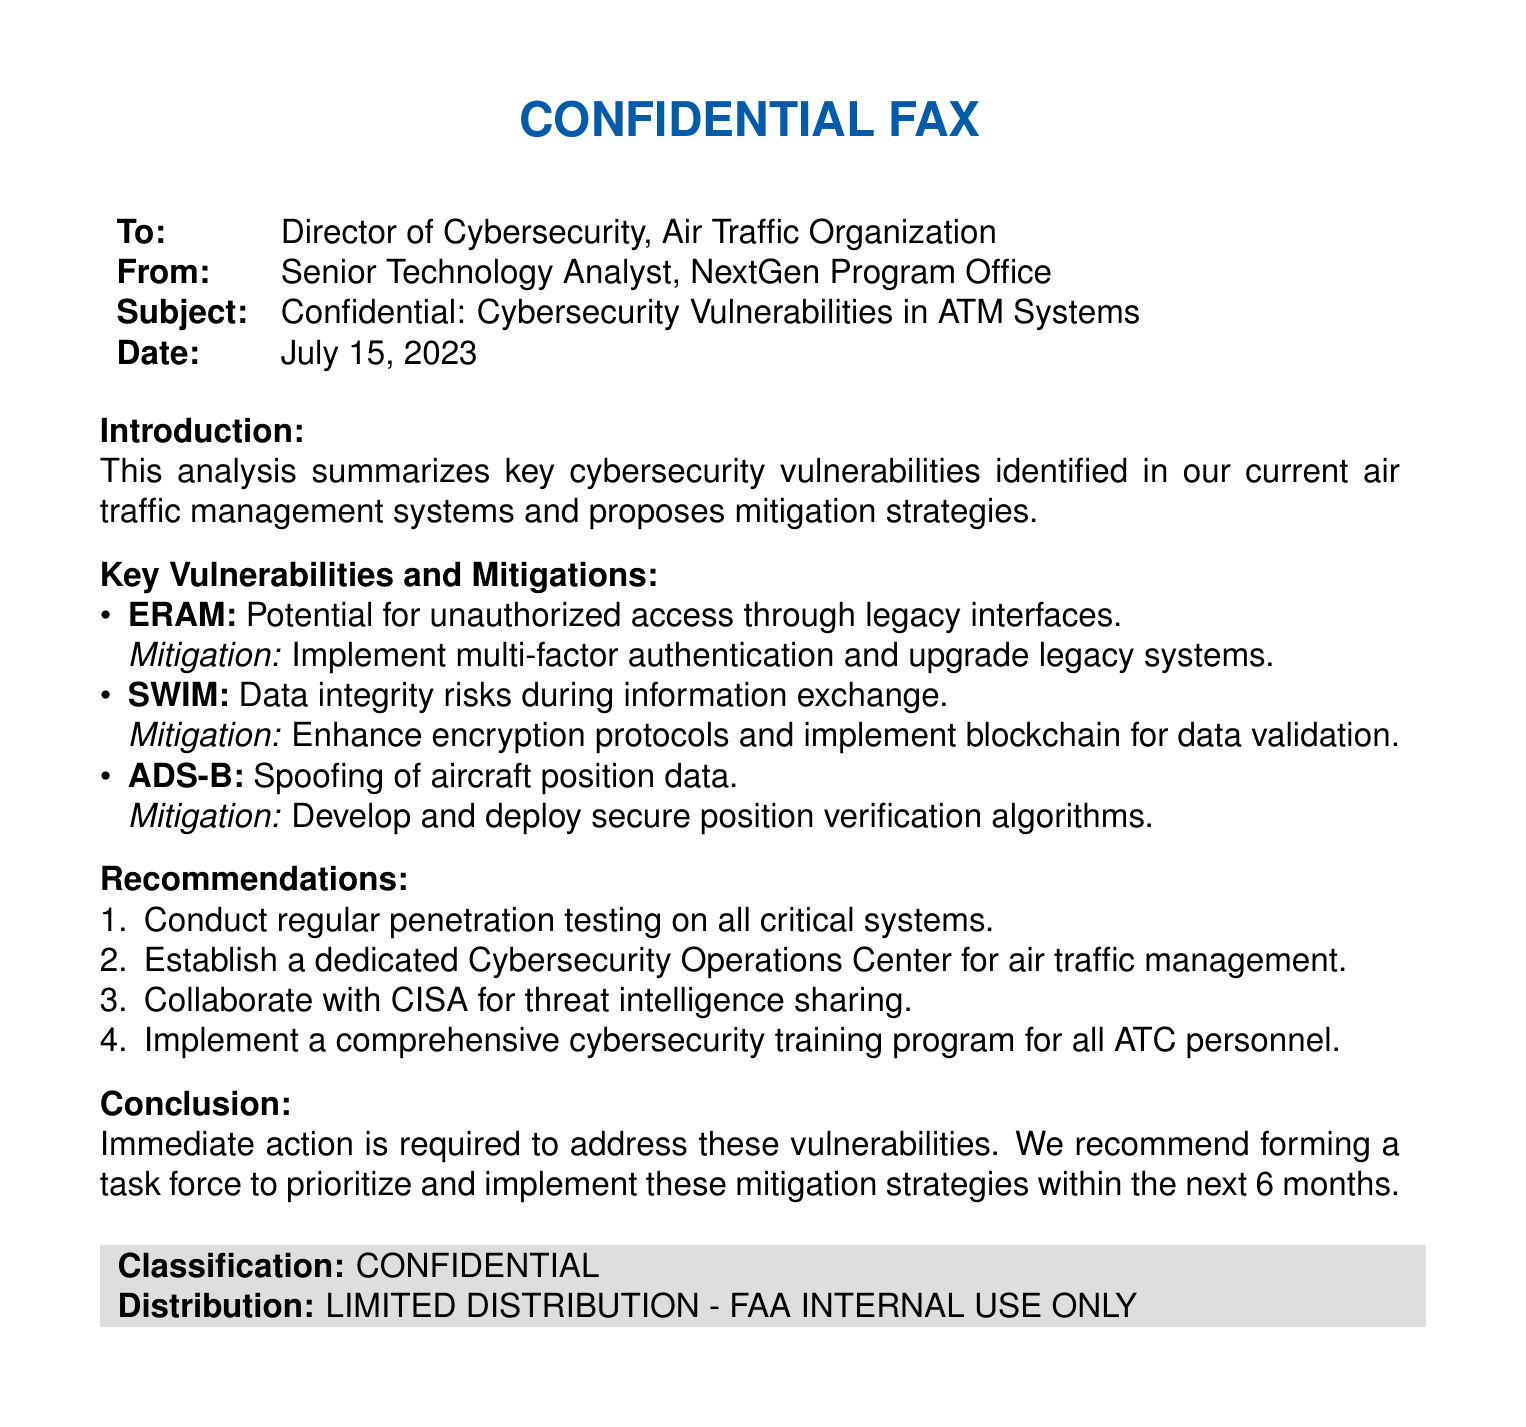what is the subject of the fax? The subject line of the fax provides a clear indication of the content it covers, which is identified as "Confidential: Cybersecurity Vulnerabilities in ATM Systems."
Answer: Confidential: Cybersecurity Vulnerabilities in ATM Systems who is the recipient of the fax? The recipient is mentioned in the "To:" section, which states it is directed to the Director of Cybersecurity, Air Traffic Organization.
Answer: Director of Cybersecurity, Air Traffic Organization what is the date of the fax? The date can be found in the "Date:" section of the fax, indicating when it was sent.
Answer: July 15, 2023 what is one of the key vulnerabilities mentioned? The document lists several key vulnerabilities, such as in the ERAM system related to unauthorized access, making this information accessible.
Answer: Potential for unauthorized access through legacy interfaces which mitigation strategy is proposed for SWIM? The document specifies a mitigation strategy related to the SWIM vulnerabilities about enhancing security: "Enhance encryption protocols and implement blockchain for data validation."
Answer: Enhance encryption protocols and implement blockchain for data validation how many recommendations are provided in the document? The recommendations section enumerates several suggestions, and counting them gives the total number of recommendations.
Answer: Four who authored the document? The author's name appears in the "From:" section of the fax, indicating who created the document.
Answer: Senior Technology Analyst, NextGen Program Office what is the classification of the document? The classification is explicitly stated at the end of the document, denoting its confidentiality level.
Answer: CONFIDENTIAL what is one proposed action regarding personnel training? The recommendations section includes a point on training, indicating a specific action recommended for personnel.
Answer: Implement a comprehensive cybersecurity training program for all ATC personnel 